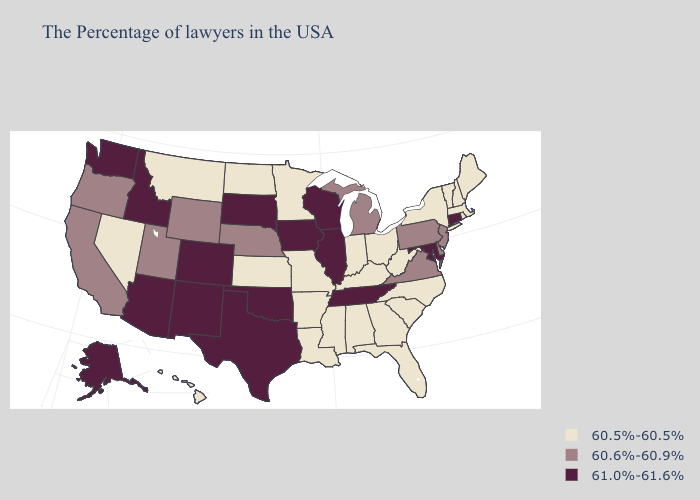Name the states that have a value in the range 60.5%-60.5%?
Give a very brief answer. Maine, Massachusetts, Rhode Island, New Hampshire, Vermont, New York, North Carolina, South Carolina, West Virginia, Ohio, Florida, Georgia, Kentucky, Indiana, Alabama, Mississippi, Louisiana, Missouri, Arkansas, Minnesota, Kansas, North Dakota, Montana, Nevada, Hawaii. What is the highest value in the USA?
Short answer required. 61.0%-61.6%. Does Arkansas have the highest value in the USA?
Give a very brief answer. No. Which states have the lowest value in the West?
Concise answer only. Montana, Nevada, Hawaii. Name the states that have a value in the range 60.5%-60.5%?
Be succinct. Maine, Massachusetts, Rhode Island, New Hampshire, Vermont, New York, North Carolina, South Carolina, West Virginia, Ohio, Florida, Georgia, Kentucky, Indiana, Alabama, Mississippi, Louisiana, Missouri, Arkansas, Minnesota, Kansas, North Dakota, Montana, Nevada, Hawaii. Does New Mexico have a higher value than Kansas?
Give a very brief answer. Yes. How many symbols are there in the legend?
Concise answer only. 3. Which states hav the highest value in the MidWest?
Keep it brief. Wisconsin, Illinois, Iowa, South Dakota. What is the highest value in the MidWest ?
Concise answer only. 61.0%-61.6%. Name the states that have a value in the range 61.0%-61.6%?
Answer briefly. Connecticut, Maryland, Tennessee, Wisconsin, Illinois, Iowa, Oklahoma, Texas, South Dakota, Colorado, New Mexico, Arizona, Idaho, Washington, Alaska. Does the first symbol in the legend represent the smallest category?
Answer briefly. Yes. Among the states that border Arizona , does Colorado have the highest value?
Quick response, please. Yes. Name the states that have a value in the range 61.0%-61.6%?
Give a very brief answer. Connecticut, Maryland, Tennessee, Wisconsin, Illinois, Iowa, Oklahoma, Texas, South Dakota, Colorado, New Mexico, Arizona, Idaho, Washington, Alaska. Name the states that have a value in the range 60.5%-60.5%?
Keep it brief. Maine, Massachusetts, Rhode Island, New Hampshire, Vermont, New York, North Carolina, South Carolina, West Virginia, Ohio, Florida, Georgia, Kentucky, Indiana, Alabama, Mississippi, Louisiana, Missouri, Arkansas, Minnesota, Kansas, North Dakota, Montana, Nevada, Hawaii. 